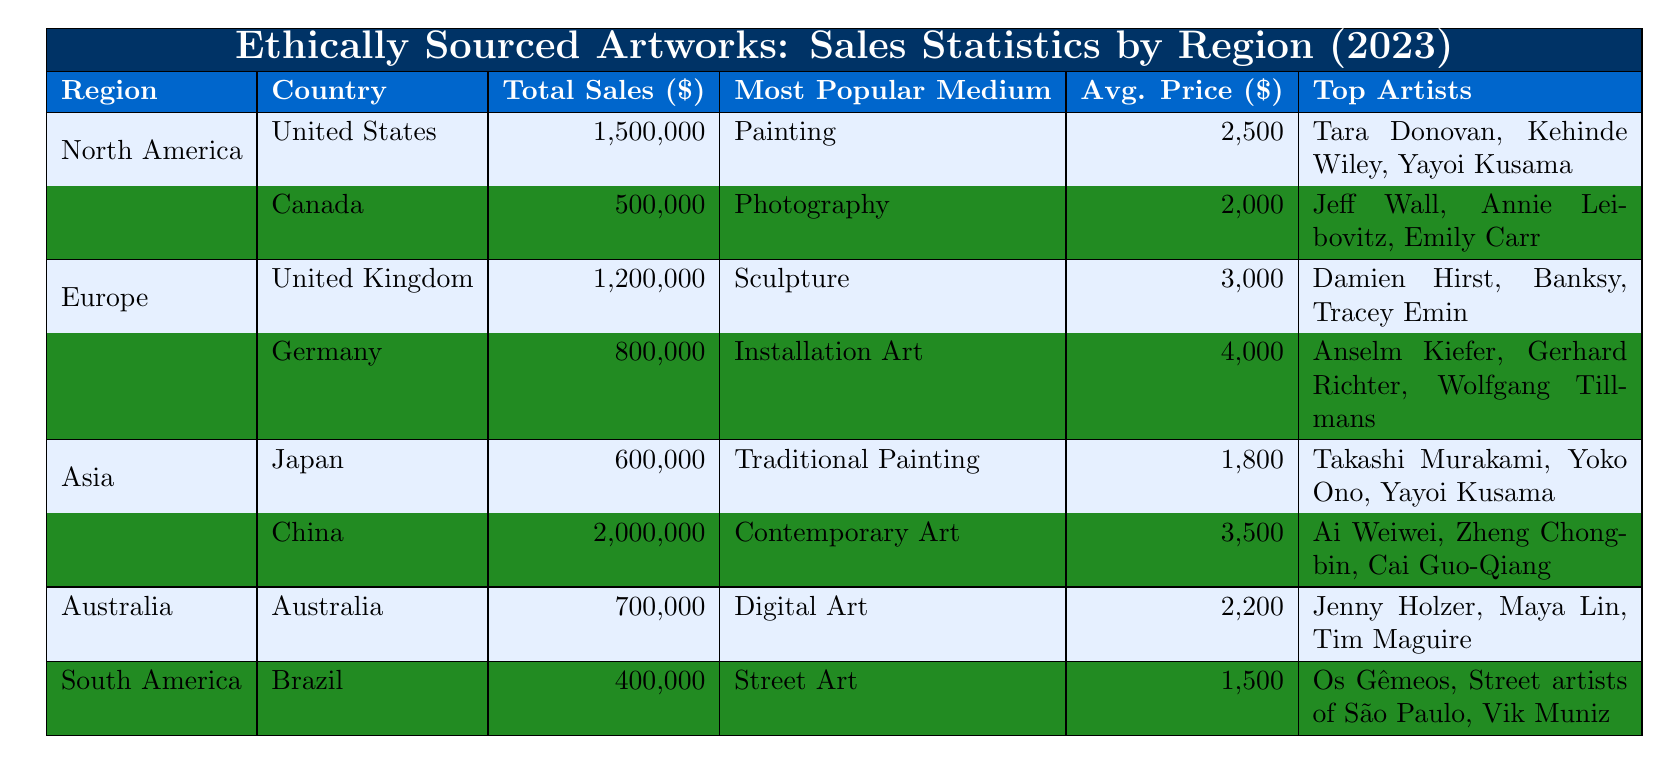What is the total sales in China? The table indicates that the Total Sales for China is 2,000,000.
Answer: 2,000,000 Which country in Europe has the highest average price for artworks? The average prices for the United Kingdom and Germany are 3,000 and 4,000 respectively. Since 4,000 is greater than 3,000, Germany has the highest average price.
Answer: Germany Who are the top three artists in the United States? The table lists Tara Donovan, Kehinde Wiley, and Yayoi Kusama as the top artists in the United States.
Answer: Tara Donovan, Kehinde Wiley, Yayoi Kusama What is the total sales in North America? To find total sales in North America, add the sales from the United States (1,500,000) and Canada (500,000): 1,500,000 + 500,000 = 2,000,000.
Answer: 2,000,000 Is the most popular medium in Canada photography? The table states that the Most Popular Medium in Canada is Photography, confirming the statement is true.
Answer: Yes Which region had the lowest total sales? The total sales for South America (400,000) are compared to others: North America (2,000,000), Europe (2,000,000), Asia (2,600,000), and Australia (700,000). South America has the lowest total sales.
Answer: South America What is the average price of a traditional painting sold in Japan? The average price for artworks categorized as Traditional Painting in Japan is indicated as 1,800.
Answer: 1,800 How much higher is the total sales in China compared to Japan? The total sales for China (2,000,000) minus Japan's (600,000) gives 2,000,000 - 600,000 = 1,400,000, showing that China's sales are 1,400,000 higher.
Answer: 1,400,000 What is the most popular medium in Australia? The table shows that the Most Popular Medium in Australia is Digital Art.
Answer: Digital Art If we consider all regions, which medium had the highest average price, and what was that average price? Calculating the average prices: North America = (2,500 + 2,000)/2 = 2,250, Europe = (3,000 + 4,000)/2 = 3,500, Asia = (1,800 + 3,500)/2 = 2,650, Australia = 2,200, South America = 1,500. The highest average price is 4,000 from Europe.
Answer: 4,000 What percentage of total sales in North America comes from the United States? The calculation is (1,500,000 / 2,000,000) * 100 = 75%. Therefore, 75% of total sales in North America come from the United States.
Answer: 75% Which artist is common to both Japan and the United States? The table indicates that Yayoi Kusama appears as a top artist in both Japan and the United States.
Answer: Yayoi Kusama 